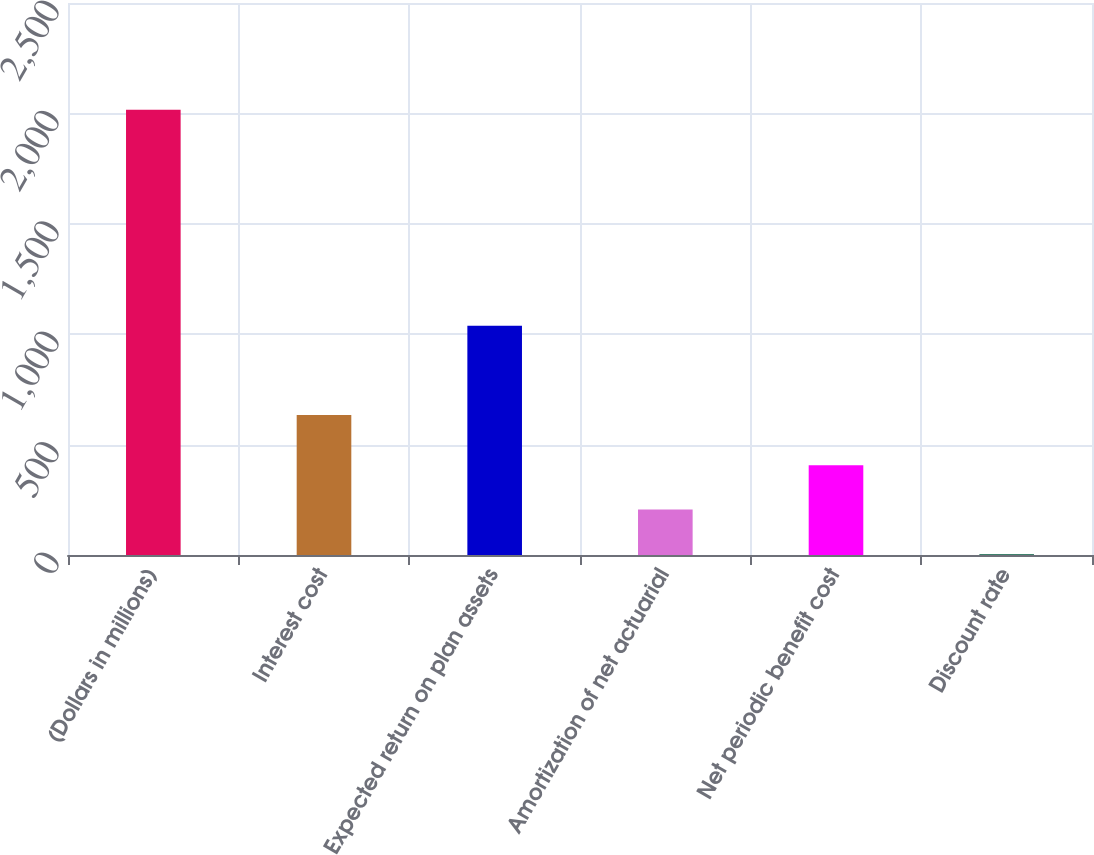<chart> <loc_0><loc_0><loc_500><loc_500><bar_chart><fcel>(Dollars in millions)<fcel>Interest cost<fcel>Expected return on plan assets<fcel>Amortization of net actuarial<fcel>Net periodic benefit cost<fcel>Discount rate<nl><fcel>2016<fcel>634<fcel>1038<fcel>205.66<fcel>406.81<fcel>4.51<nl></chart> 